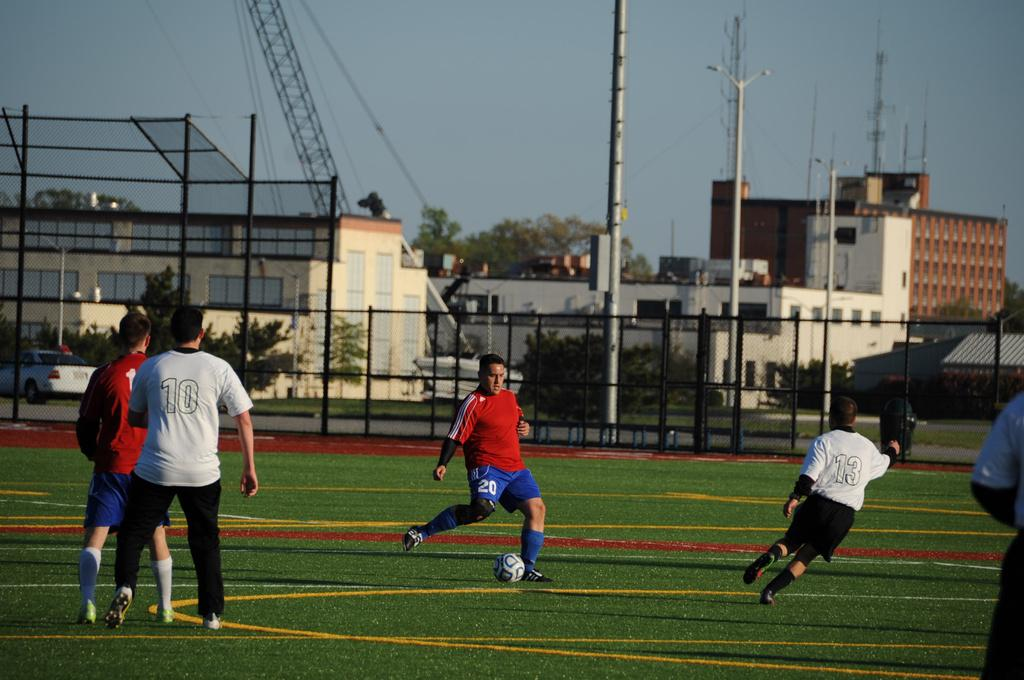What is the main setting of the image? The image depicts a ground. What are the people in the image doing? The people are playing in the middle of the image. What other objects or structures can be seen in the middle of the image? There are buildings and trees in the middle of the image. What is visible at the top of the image? The sky is visible at the top of the image. What type of shirt is the tree wearing in the image? Trees do not wear shirts, as they are plants and not people. How does the haircut of the building contribute to the overall aesthetic of the image? Buildings do not have haircuts, as they are inanimate structures and not living beings. 